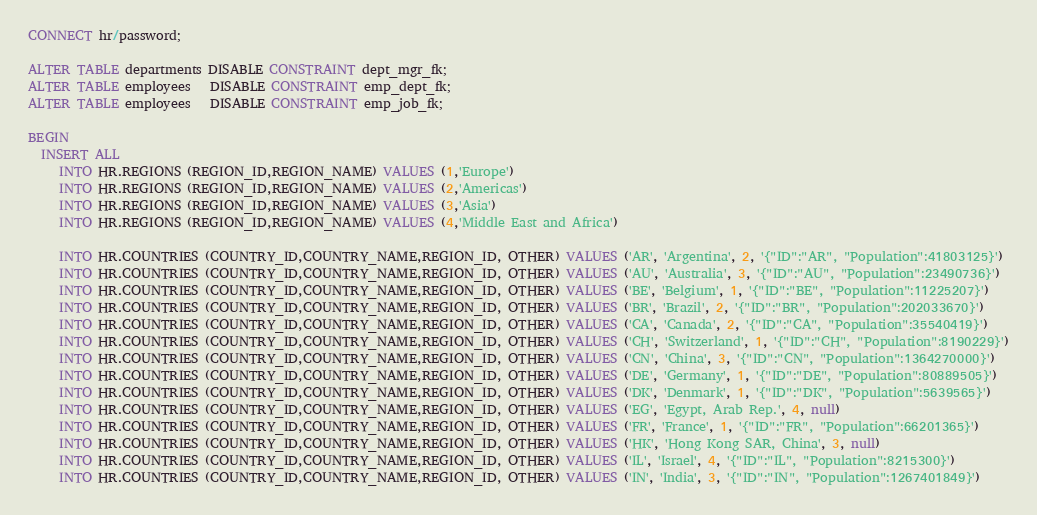<code> <loc_0><loc_0><loc_500><loc_500><_SQL_>CONNECT hr/password;

ALTER TABLE departments DISABLE CONSTRAINT dept_mgr_fk;
ALTER TABLE employees   DISABLE CONSTRAINT emp_dept_fk;
ALTER TABLE employees   DISABLE CONSTRAINT emp_job_fk;

BEGIN
  INSERT ALL
     INTO HR.REGIONS (REGION_ID,REGION_NAME) VALUES (1,'Europe')
     INTO HR.REGIONS (REGION_ID,REGION_NAME) VALUES (2,'Americas')
     INTO HR.REGIONS (REGION_ID,REGION_NAME) VALUES (3,'Asia')
     INTO HR.REGIONS (REGION_ID,REGION_NAME) VALUES (4,'Middle East and Africa')

     INTO HR.COUNTRIES (COUNTRY_ID,COUNTRY_NAME,REGION_ID, OTHER) VALUES ('AR', 'Argentina', 2, '{"ID":"AR", "Population":41803125}')
     INTO HR.COUNTRIES (COUNTRY_ID,COUNTRY_NAME,REGION_ID, OTHER) VALUES ('AU', 'Australia', 3, '{"ID":"AU", "Population":23490736}')
     INTO HR.COUNTRIES (COUNTRY_ID,COUNTRY_NAME,REGION_ID, OTHER) VALUES ('BE', 'Belgium', 1, '{"ID":"BE", "Population":11225207}')
     INTO HR.COUNTRIES (COUNTRY_ID,COUNTRY_NAME,REGION_ID, OTHER) VALUES ('BR', 'Brazil', 2, '{"ID":"BR", "Population":202033670}')
     INTO HR.COUNTRIES (COUNTRY_ID,COUNTRY_NAME,REGION_ID, OTHER) VALUES ('CA', 'Canada', 2, '{"ID":"CA", "Population":35540419}')
     INTO HR.COUNTRIES (COUNTRY_ID,COUNTRY_NAME,REGION_ID, OTHER) VALUES ('CH', 'Switzerland', 1, '{"ID":"CH", "Population":8190229}')
     INTO HR.COUNTRIES (COUNTRY_ID,COUNTRY_NAME,REGION_ID, OTHER) VALUES ('CN', 'China', 3, '{"ID":"CN", "Population":1364270000}')
     INTO HR.COUNTRIES (COUNTRY_ID,COUNTRY_NAME,REGION_ID, OTHER) VALUES ('DE', 'Germany', 1, '{"ID":"DE", "Population":80889505}')
     INTO HR.COUNTRIES (COUNTRY_ID,COUNTRY_NAME,REGION_ID, OTHER) VALUES ('DK', 'Denmark', 1, '{"ID":"DK", "Population":5639565}')
     INTO HR.COUNTRIES (COUNTRY_ID,COUNTRY_NAME,REGION_ID, OTHER) VALUES ('EG', 'Egypt, Arab Rep.', 4, null)
     INTO HR.COUNTRIES (COUNTRY_ID,COUNTRY_NAME,REGION_ID, OTHER) VALUES ('FR', 'France', 1, '{"ID":"FR", "Population":66201365}')
     INTO HR.COUNTRIES (COUNTRY_ID,COUNTRY_NAME,REGION_ID, OTHER) VALUES ('HK', 'Hong Kong SAR, China', 3, null)
     INTO HR.COUNTRIES (COUNTRY_ID,COUNTRY_NAME,REGION_ID, OTHER) VALUES ('IL', 'Israel', 4, '{"ID":"IL", "Population":8215300}')
     INTO HR.COUNTRIES (COUNTRY_ID,COUNTRY_NAME,REGION_ID, OTHER) VALUES ('IN', 'India', 3, '{"ID":"IN", "Population":1267401849}')</code> 